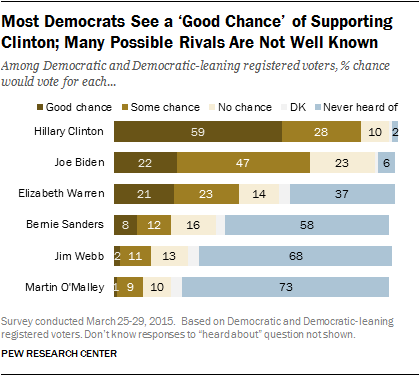Outline some significant characteristics in this image. The difference between the largest and smallest blue bars is 71. 